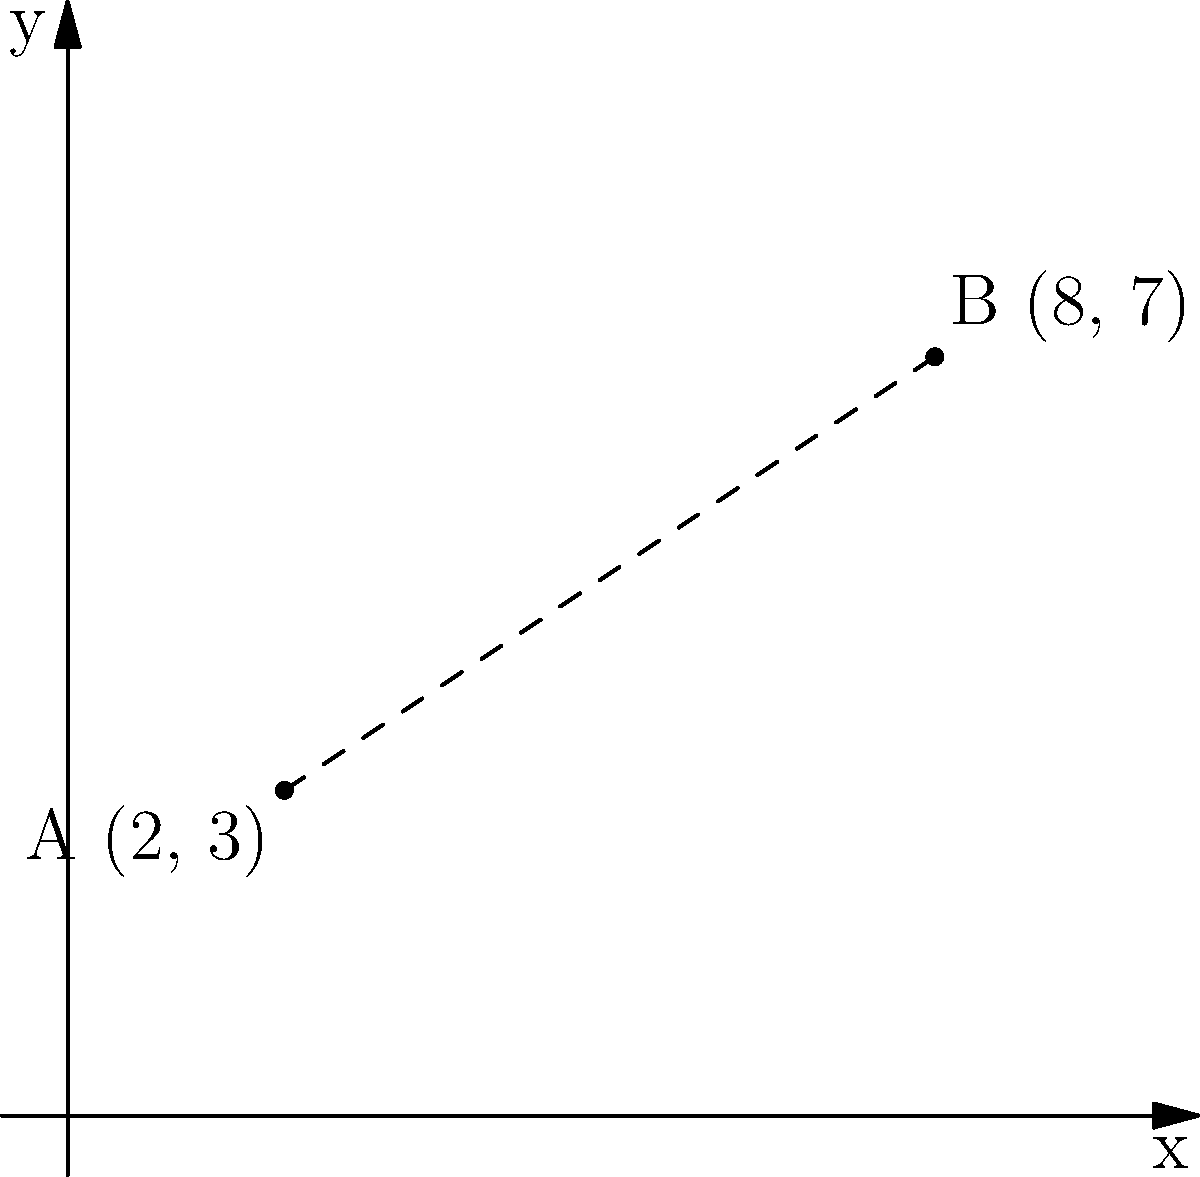In a TV series, the emotional journey of two main characters is represented on a coordinate plane. Character A starts at point (2, 3), representing their initial emotional state. As the series progresses, character B ends up at point (8, 7), showing their final emotional state. Calculate the emotional distance between these two characters, knowing that a greater distance indicates a more dramatic character development. How would you rate the intensity of character development in this series finale on a scale of 1-10, if a distance of 10 units is considered extremely dramatic? To solve this problem, we'll follow these steps:

1) First, we need to calculate the distance between points A(2, 3) and B(8, 7) using the distance formula:

   $$d = \sqrt{(x_2 - x_1)^2 + (y_2 - y_1)^2}$$

2) Let's plug in the values:
   $$d = \sqrt{(8 - 2)^2 + (7 - 3)^2}$$

3) Simplify:
   $$d = \sqrt{6^2 + 4^2} = \sqrt{36 + 16} = \sqrt{52}$$

4) Calculate the square root:
   $$d \approx 7.21$$

5) Now, we need to rate this on a scale of 1-10, where a distance of 10 units is considered extremely dramatic (i.e., a 10 on the scale).

6) We can set up a proportion:
   $$\frac{7.21}{10} = \frac{x}{10}$$

7) Solve for x:
   $$x = \frac{7.21 \times 10}{10} = 7.21$$

8) Rounding to the nearest whole number (as it's a 1-10 scale), we get 7.

Therefore, the intensity of character development in this series finale would rate as a 7 out of 10 on the dramatic scale.
Answer: 7 out of 10 